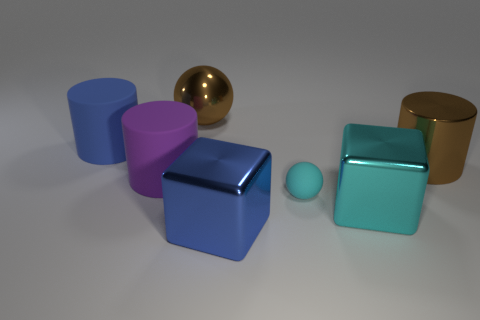Subtract all blue cylinders. How many cylinders are left? 2 Subtract 1 cylinders. How many cylinders are left? 2 Subtract all purple cylinders. How many cylinders are left? 2 Subtract all green blocks. Subtract all blue cylinders. How many blocks are left? 2 Subtract all red cylinders. How many gray spheres are left? 0 Subtract all yellow matte cubes. Subtract all blue metallic blocks. How many objects are left? 6 Add 7 large brown metallic objects. How many large brown metallic objects are left? 9 Add 6 big gray matte cylinders. How many big gray matte cylinders exist? 6 Add 1 purple matte spheres. How many objects exist? 8 Subtract 0 brown blocks. How many objects are left? 7 